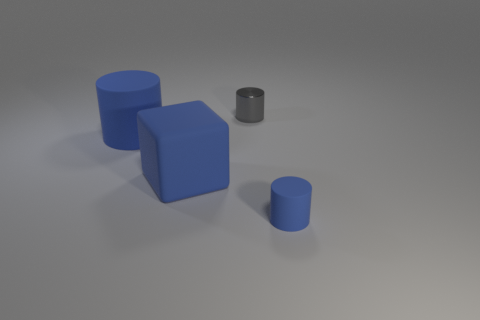What is the cylinder behind the matte cylinder that is left of the blue thing on the right side of the tiny gray shiny cylinder made of?
Your answer should be very brief. Metal. How many things are blue things that are behind the big blue rubber block or small blue rubber things?
Offer a terse response. 2. What number of things are either big gray metal objects or metal objects that are on the right side of the big matte cube?
Offer a very short reply. 1. How many large blue things are behind the blue cylinder that is right of the blue rubber cylinder on the left side of the tiny blue cylinder?
Your answer should be very brief. 2. What is the material of the cylinder that is the same size as the gray object?
Offer a very short reply. Rubber. Are there any gray shiny cylinders of the same size as the blue rubber block?
Keep it short and to the point. No. What color is the cube?
Give a very brief answer. Blue. There is a small thing that is behind the small object that is in front of the big cylinder; what color is it?
Provide a short and direct response. Gray. There is a tiny object behind the tiny thing that is in front of the large object behind the large blue block; what shape is it?
Provide a short and direct response. Cylinder. How many gray objects have the same material as the large cylinder?
Offer a very short reply. 0. 